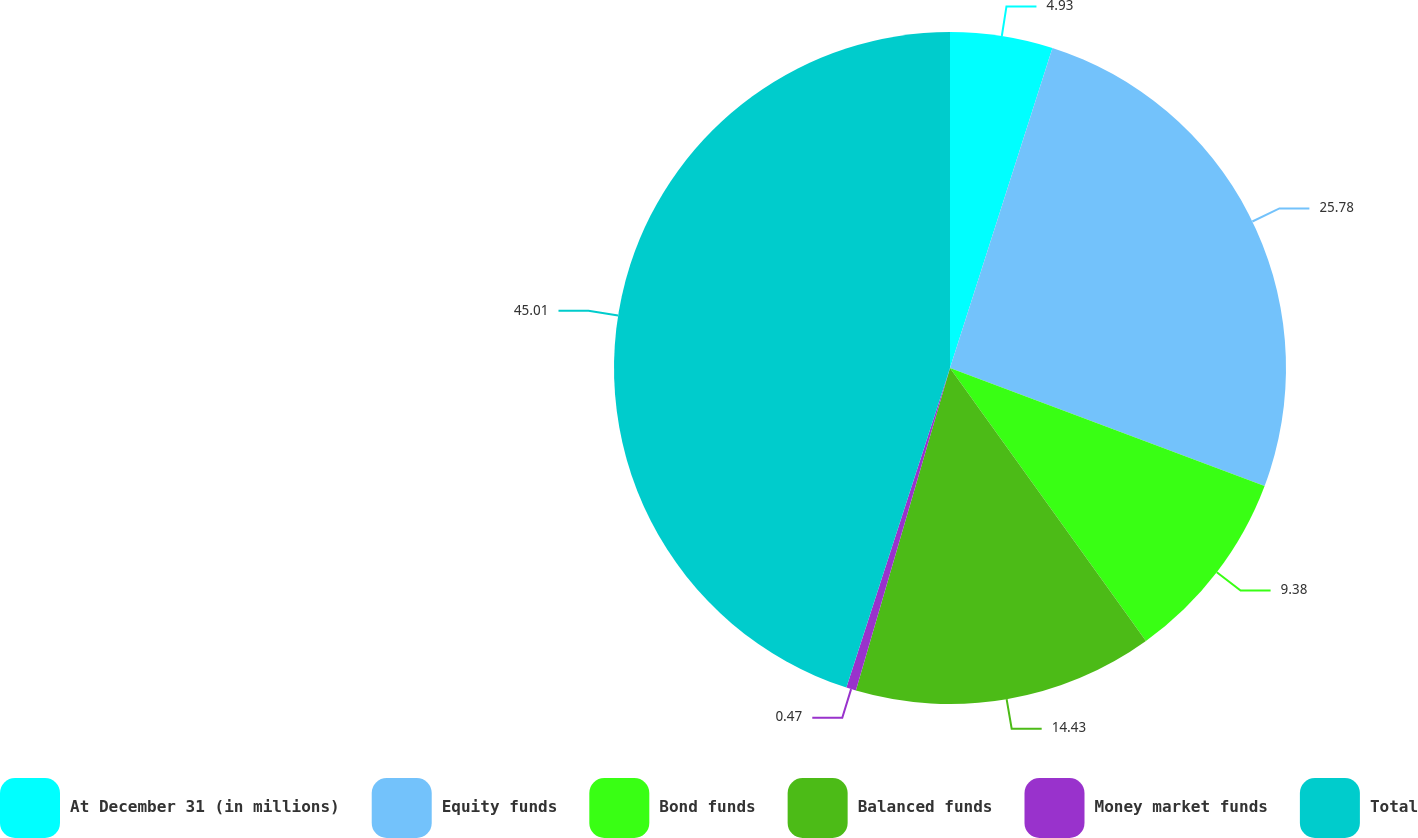Convert chart to OTSL. <chart><loc_0><loc_0><loc_500><loc_500><pie_chart><fcel>At December 31 (in millions)<fcel>Equity funds<fcel>Bond funds<fcel>Balanced funds<fcel>Money market funds<fcel>Total<nl><fcel>4.93%<fcel>25.78%<fcel>9.38%<fcel>14.43%<fcel>0.47%<fcel>45.01%<nl></chart> 